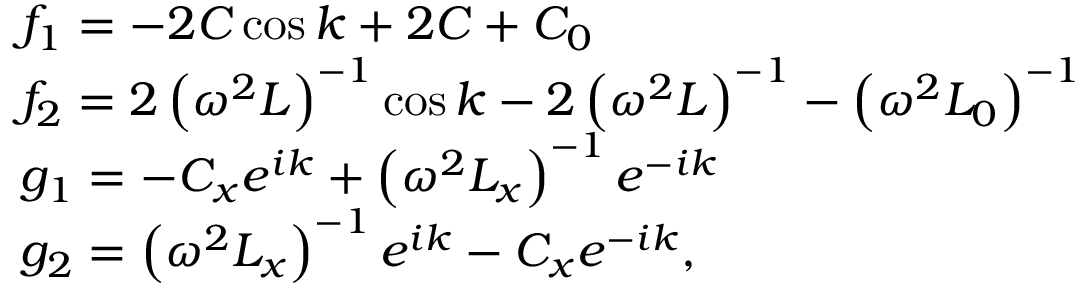Convert formula to latex. <formula><loc_0><loc_0><loc_500><loc_500>\begin{array} { r l } & { f _ { 1 } = - 2 C \cos k + 2 C + C _ { 0 } } \\ & { f _ { 2 } = 2 \left ( \omega ^ { 2 } L \right ) ^ { - 1 } \cos k - 2 \left ( \omega ^ { 2 } L \right ) ^ { - 1 } - \left ( \omega ^ { 2 } L _ { 0 } \right ) ^ { - 1 } } \\ & { g _ { 1 } = - C _ { x } e ^ { i k } + \left ( \omega ^ { 2 } L _ { x } \right ) ^ { - 1 } e ^ { - i k } } \\ & { g _ { 2 } = \left ( \omega ^ { 2 } L _ { x } \right ) ^ { - 1 } e ^ { i k } - C _ { x } e ^ { - i k } , } \end{array}</formula> 